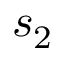Convert formula to latex. <formula><loc_0><loc_0><loc_500><loc_500>s _ { 2 }</formula> 